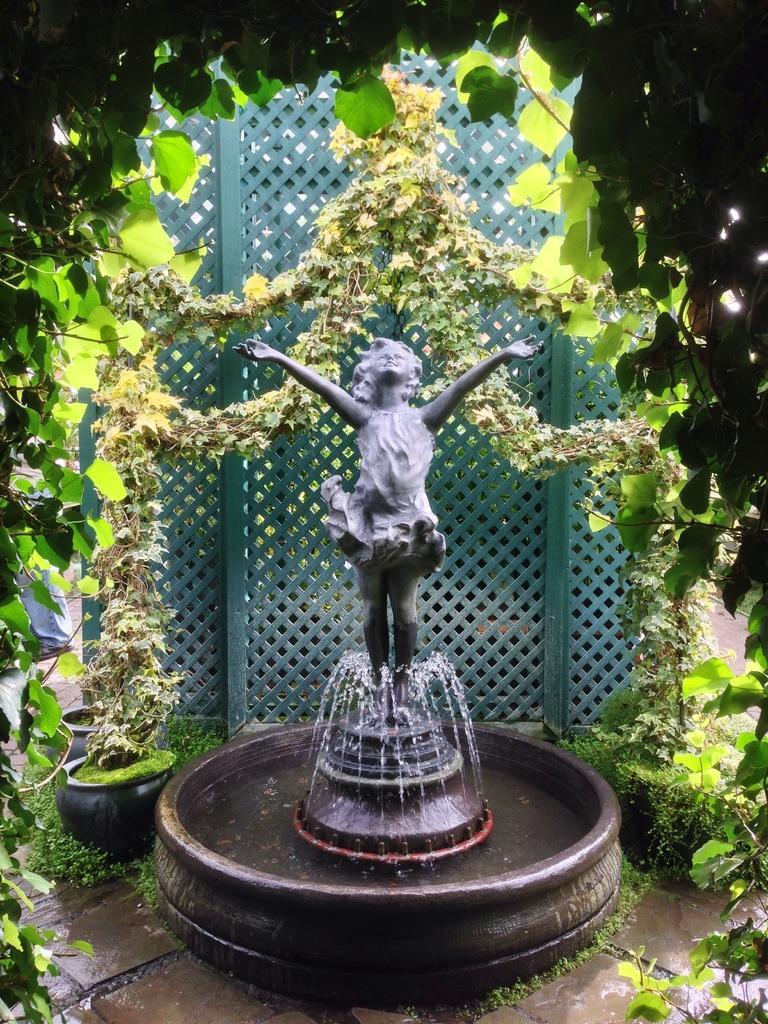How would you summarize this image in a sentence or two? In this image I can see a statue, I can also see a fountain, background I can see few plants in green color and I can see green color railing. 